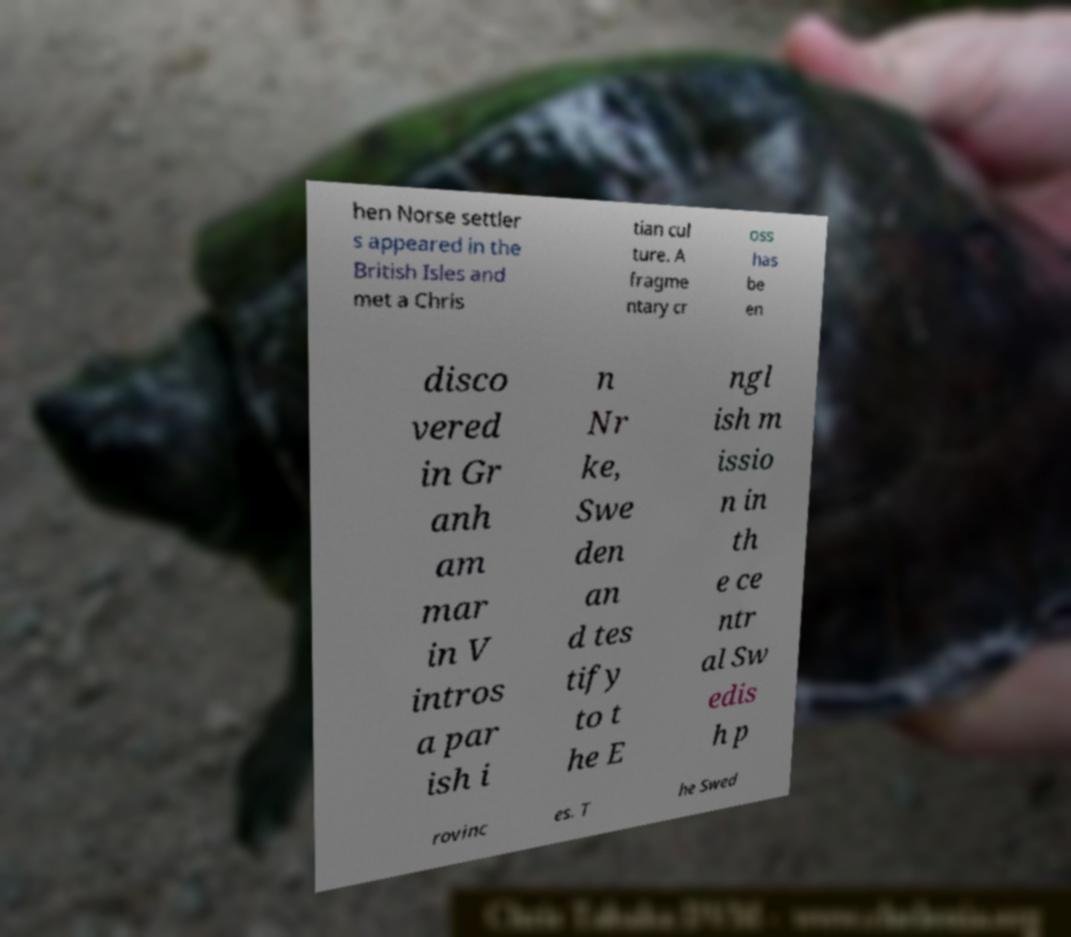Could you assist in decoding the text presented in this image and type it out clearly? hen Norse settler s appeared in the British Isles and met a Chris tian cul ture. A fragme ntary cr oss has be en disco vered in Gr anh am mar in V intros a par ish i n Nr ke, Swe den an d tes tify to t he E ngl ish m issio n in th e ce ntr al Sw edis h p rovinc es. T he Swed 